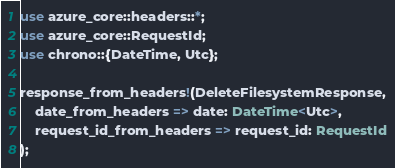<code> <loc_0><loc_0><loc_500><loc_500><_Rust_>use azure_core::headers::*;
use azure_core::RequestId;
use chrono::{DateTime, Utc};

response_from_headers!(DeleteFilesystemResponse,
    date_from_headers => date: DateTime<Utc>,
    request_id_from_headers => request_id: RequestId
);
</code> 